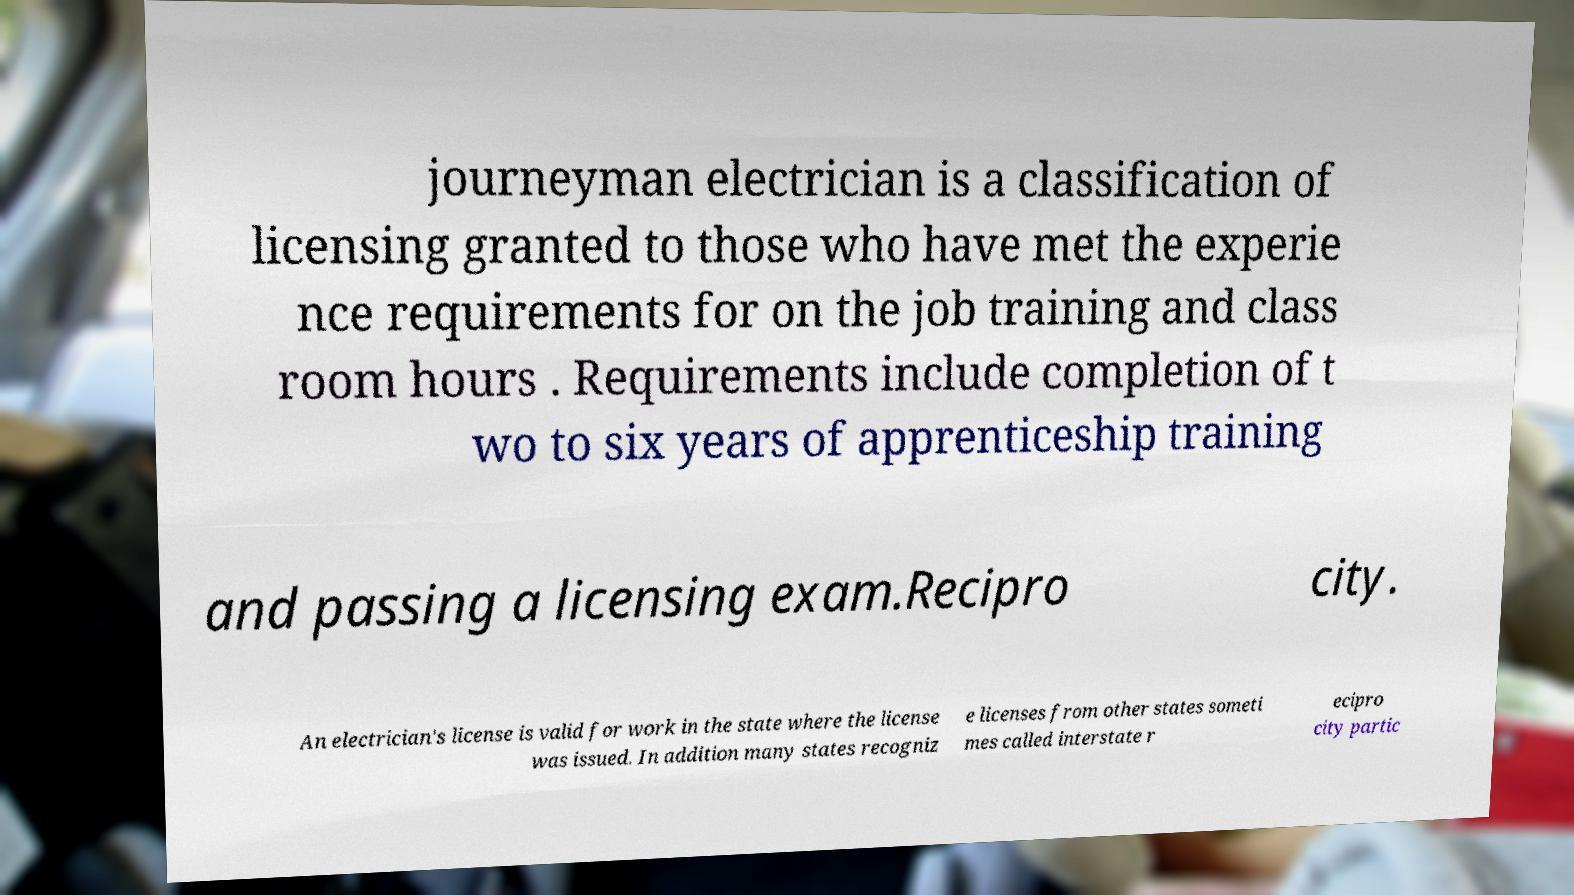Please read and relay the text visible in this image. What does it say? journeyman electrician is a classification of licensing granted to those who have met the experie nce requirements for on the job training and class room hours . Requirements include completion of t wo to six years of apprenticeship training and passing a licensing exam.Recipro city. An electrician's license is valid for work in the state where the license was issued. In addition many states recogniz e licenses from other states someti mes called interstate r ecipro city partic 